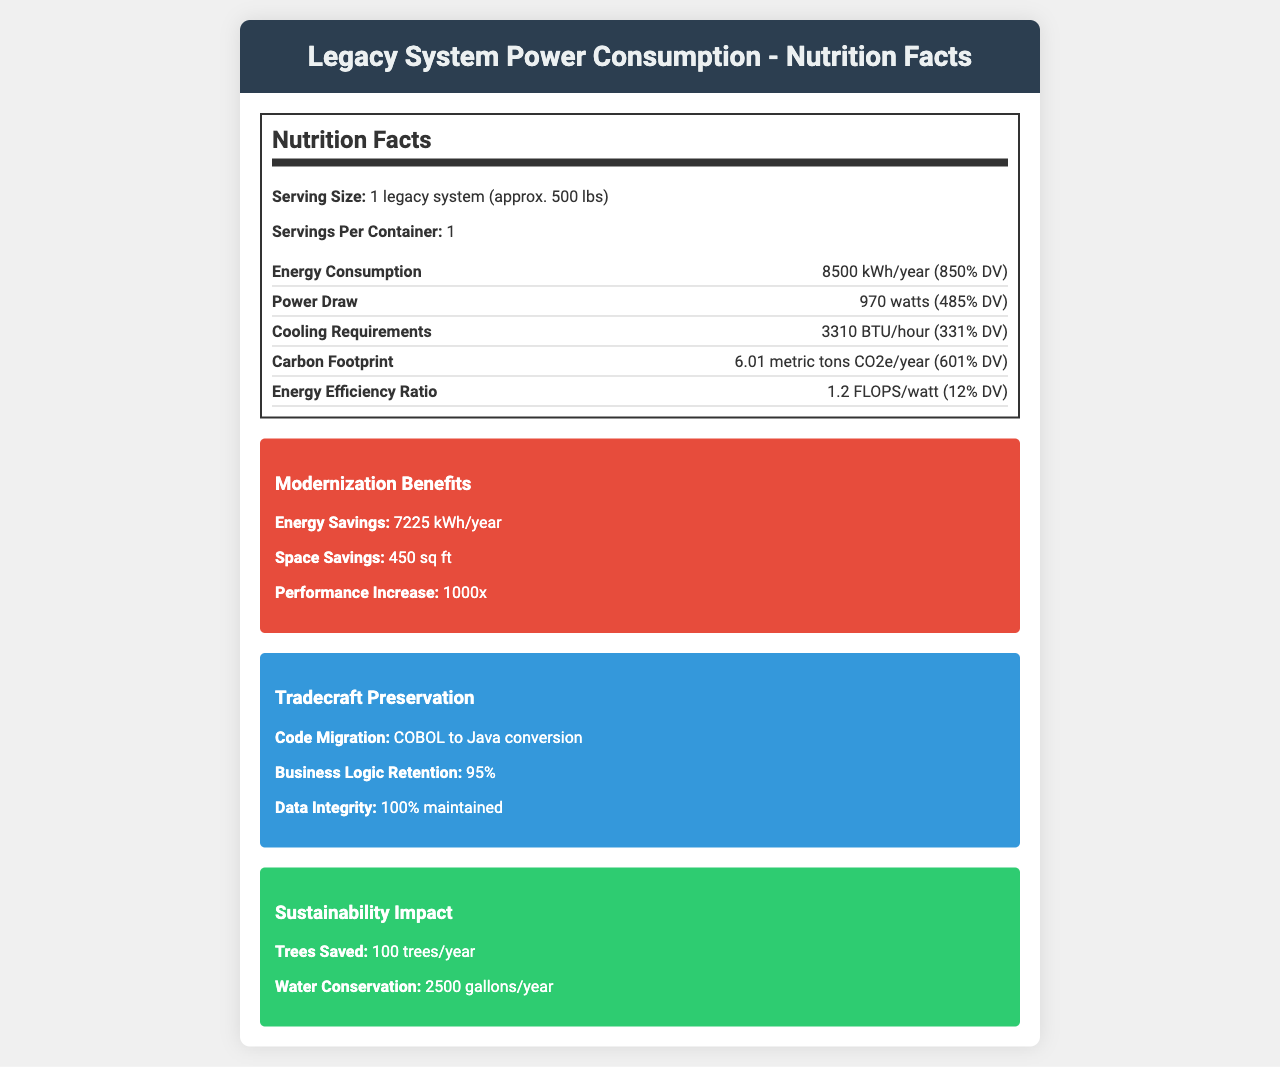what is the serving size? The document lists the serving size under the "Nutrition Facts" section as "1 legacy system (approx. 500 lbs)".
Answer: 1 legacy system (approx. 500 lbs) how many servings are there per container? Under the "Nutrition Facts" section, it specifies "Servings Per Container: 1".
Answer: 1 what is the energy consumption of the legacy system per year? The document reports an "Energy Consumption" value of 8500 kWh/year.
Answer: 8500 kWh/year what is the value of the energy efficiency ratio of the legacy system? The document states the "Energy Efficiency Ratio" as 1.2 FLOPS/watt.
Answer: 1.2 FLOPS/watt how much carbon footprint does the legacy system produce per year? The "Carbon Footprint" is listed as 6.01 metric tons CO2e/year in the document.
Answer: 6.01 metric tons CO2e/year which of the following components is included in the legacy system? A. HP 690 Drive B. IBM 3380 disk storage C. Seagate HDD The document lists "legacy components" and specifically includes "IBM 3380 disk storage".
Answer: B what is the power draw of the legacy system in watts? Under "Power Draw," the document lists 970 watts.
Answer: 970 watts how much energy can be saved per year by modernizing the legacy system? The "Modernization Benefits" section notes an energy savings of 7225 kWh/year.
Answer: 7225 kWh/year does the modernization effort lead to an increase in system performance? Under "Modernization Benefits," it mentions a "Performance Increase" of 1000 times.
Answer: Yes what is the new energy consumption after modernization using the Dell PowerEdge R750? A. 1275 kWh/year B. 20000 FLOPS/watt C. 8500 kWh/year The "Modern Equivalent" section states that the Dell PowerEdge R750 has an energy consumption of 1275 kWh/year.
Answer: A what is the cooling requirement of the legacy system? The "Cooling Requirements" section specifies a value of 3310 BTU/hour.
Answer: 3310 BTU/hour how many trees can be saved per year by modernizing the legacy system? Under the "Sustainability Impact" section, it is stated that 100 trees can be saved per year.
Answer: 100 trees/year what is the decrease in cooling load after modernization? The "Data Center Impact" section indicates a decrease in cooling load of 85%.
Answer: 85% can you determine the initial cost of the legacy system from the document? The document doesn't provide any information regarding the initial cost of the legacy system.
Answer: Cannot be determined summarize the main idea of the document. The document is formatted similarly to a nutritional label and contrasts the legacy system's specifications with the benefits gained from upgrading to a modern equivalent. It highlights key areas like energy savings, sustainability impacts, and preservation of coding and business logic to emphasize the advantages of modernization.
Answer: The document presents a detailed "Nutrition Facts" style breakdown of a legacy computer system's power consumption along with the benefits of modernizing to a newer system. It emphasizes energy efficiency improvements, carbon footprint reduction, and various cost savings, while also discussing the preservation of tradecraft elements during the modernization process. 